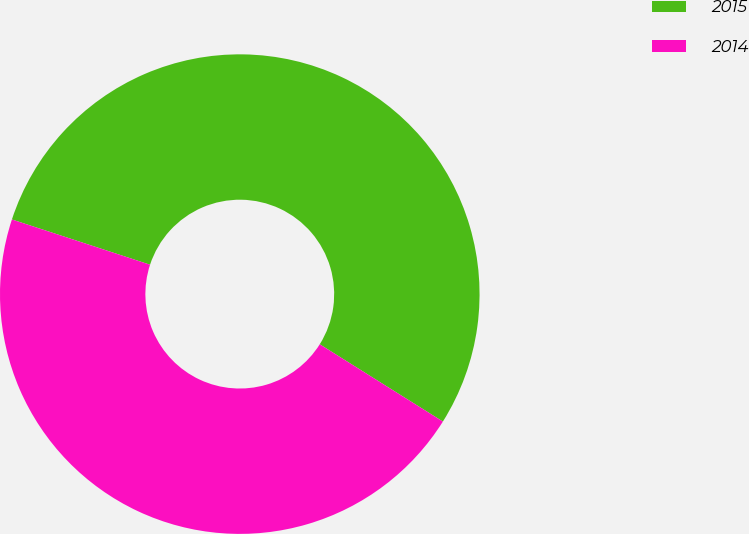Convert chart to OTSL. <chart><loc_0><loc_0><loc_500><loc_500><pie_chart><fcel>2015<fcel>2014<nl><fcel>53.88%<fcel>46.12%<nl></chart> 